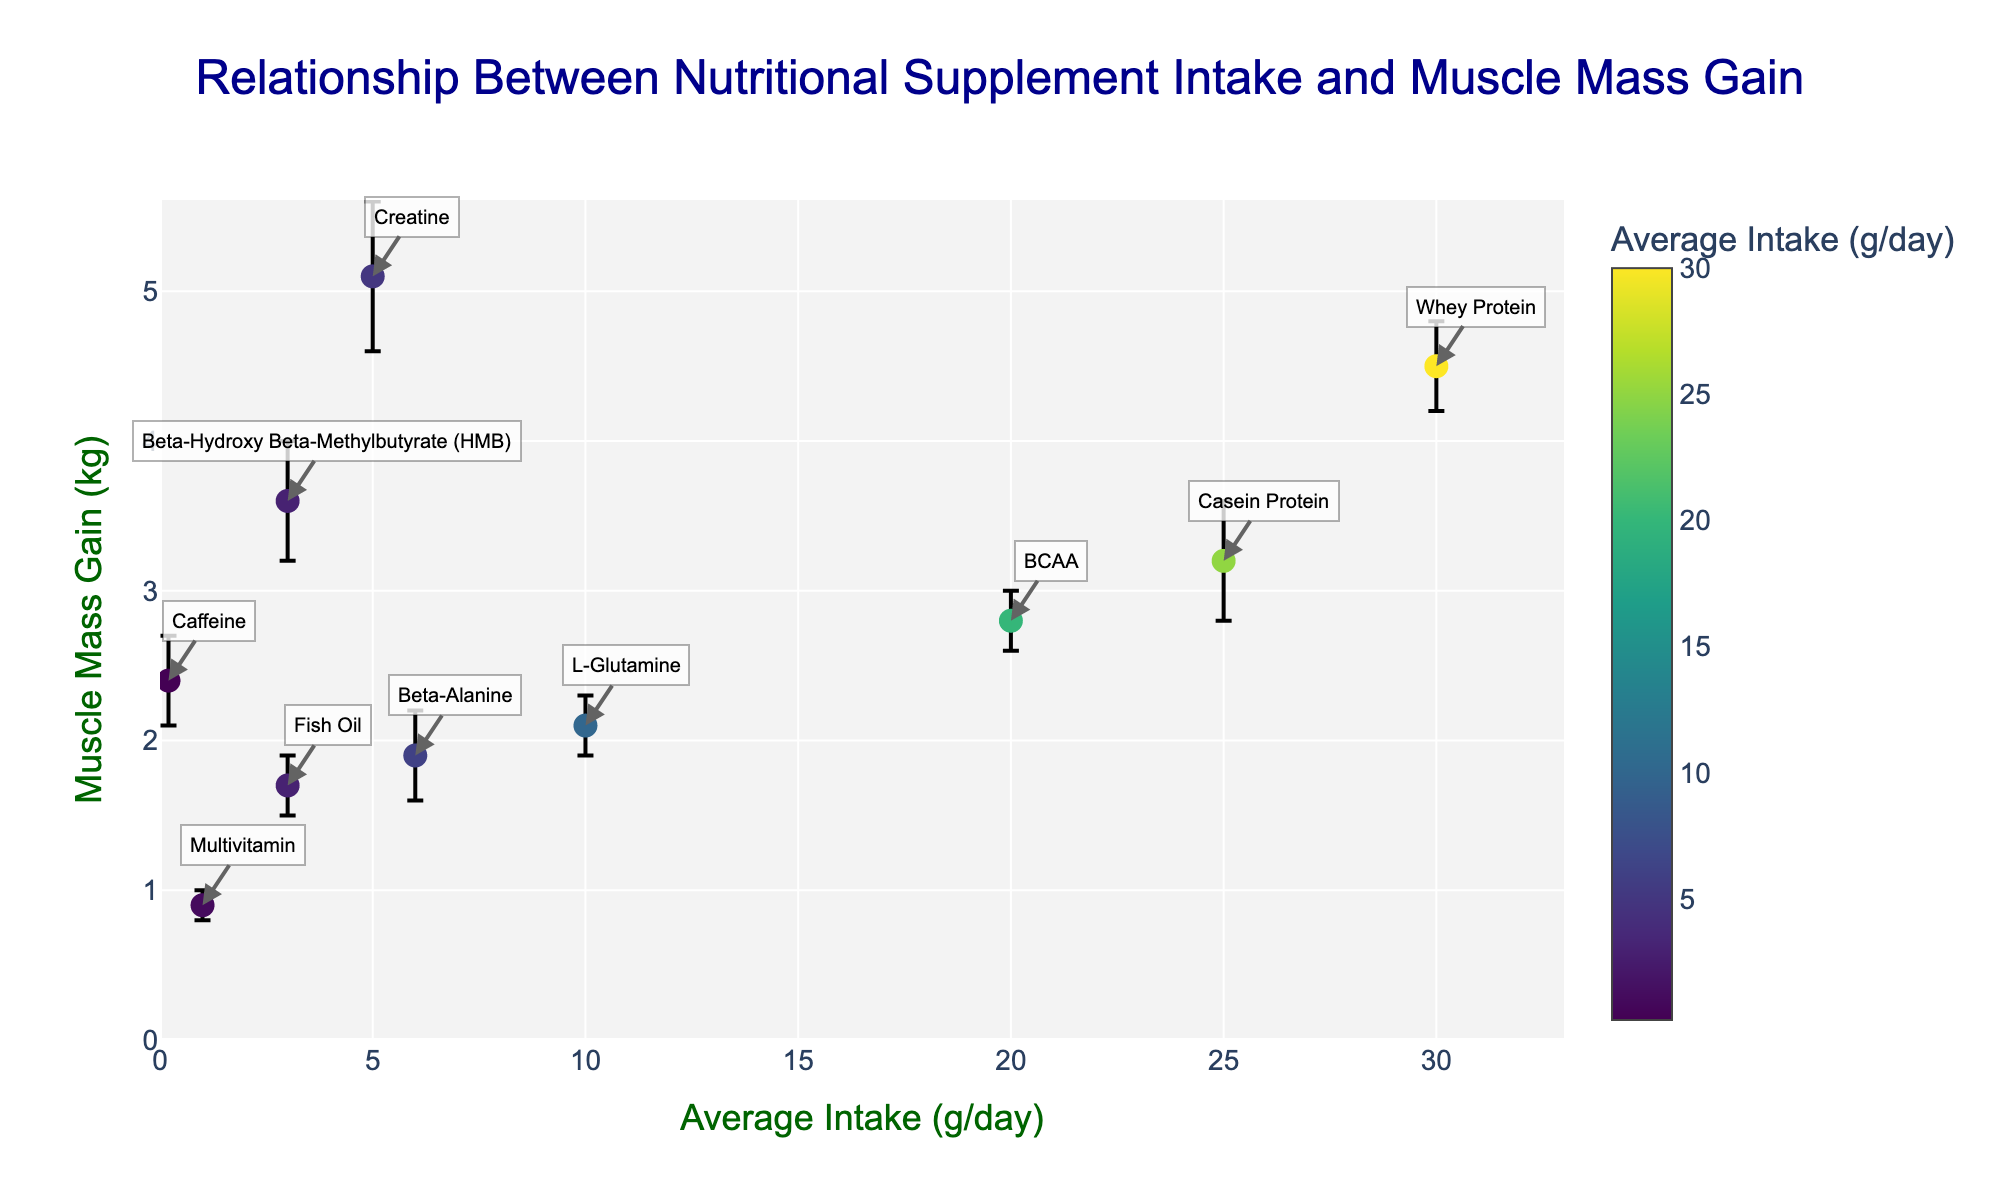What's the title of the figure? The title of the figure is typically placed at the top center of the chart. In this chart, it's clearly written with a large font size.
Answer: Relationship Between Nutritional Supplement Intake and Muscle Mass Gain What does the x-axis represent? The x-axis is labeled, which indicates it represents the average intake of the nutritional supplement in grams per day.
Answer: Average Intake (g/day) What does the y-axis represent? The y-axis is labeled as well, which indicates it measures the muscle mass gain in kilograms.
Answer: Muscle Mass Gain (kg) How many data points are there in the figure? Each marker on the scatter plot represents a data point. By counting these markers, we can determine the number of data points.
Answer: 10 Which nutritional supplement has the highest muscle mass gain? By identifying the highest point on the y-axis and checking the corresponding label, we can determine which supplement results in the highest muscle mass gain.
Answer: Creatine What is the average intake and muscle mass gain error for Whey Protein? Locate the marker labeled "Whey Protein". The hover-text provides the necessary details for average intake and muscle mass gain error.
Answer: 30 g/day, 0.3 kg Compare the muscle mass gain between Beta-Alanine and Fish Oil. Locate the markers for Beta-Alanine and Fish Oil on the plot. Beta-Alanine (6 g/day) results in a muscle mass gain of 1.9 kg, while Fish Oil (3 g/day) results in a muscle mass gain of 1.7 kg.
Answer: Beta-Alanine Which supplement has the largest error in muscle mass gain? Check the error bars for each supplement and identify the one with the largest span.
Answer: Creatine If a supplement's average intake is below 10 g/day, what is the maximum muscle mass gain observed? Identify supplements with an intake of less than 10 g/day and find the maximum muscle mass gain among them.
Answer: HMB with 3.6 kg What is the total muscle mass gain for Whey Protein, Casein Protein, and BCAA combined? Add the muscle mass gains for these three supplements: 4.5 kg for Whey Protein, 3.2 kg for Casein Protein, and 2.8 kg for BCAA. 4.5 + 3.2 + 2.8 = 10.5 kg
Answer: 10.5 kg 